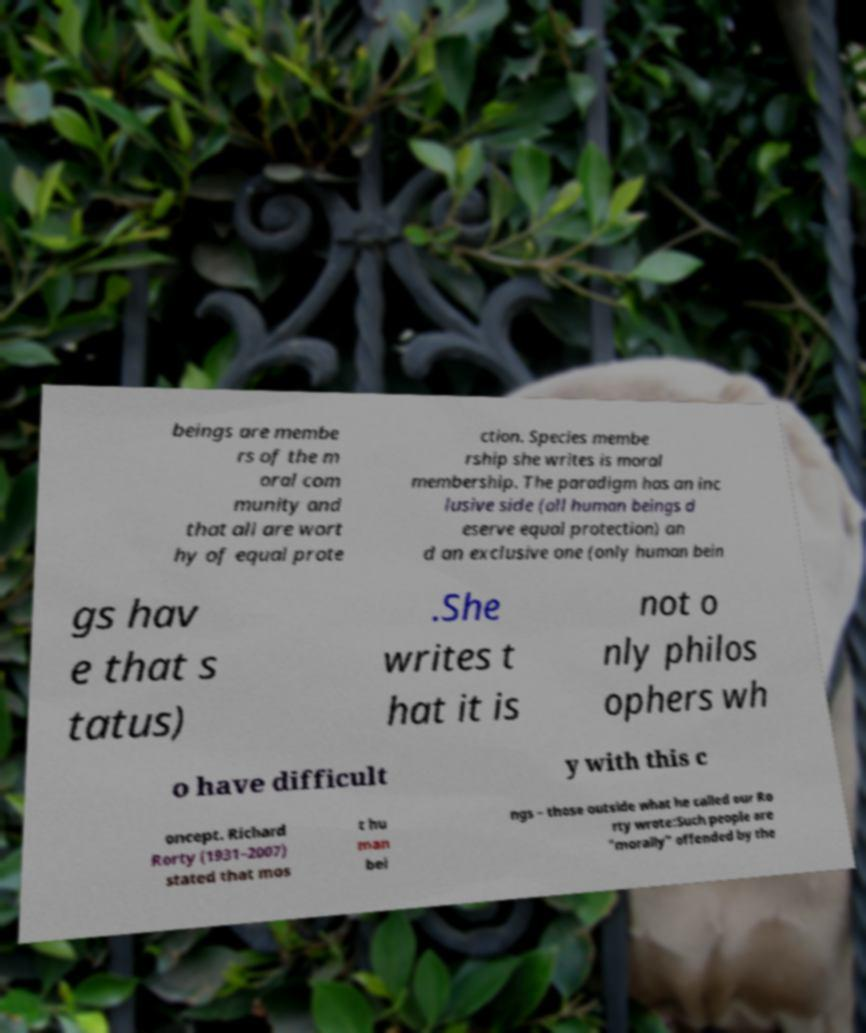What messages or text are displayed in this image? I need them in a readable, typed format. beings are membe rs of the m oral com munity and that all are wort hy of equal prote ction. Species membe rship she writes is moral membership. The paradigm has an inc lusive side (all human beings d eserve equal protection) an d an exclusive one (only human bein gs hav e that s tatus) .She writes t hat it is not o nly philos ophers wh o have difficult y with this c oncept. Richard Rorty (1931–2007) stated that mos t hu man bei ngs – those outside what he called our Ro rty wrote:Such people are "morally" offended by the 